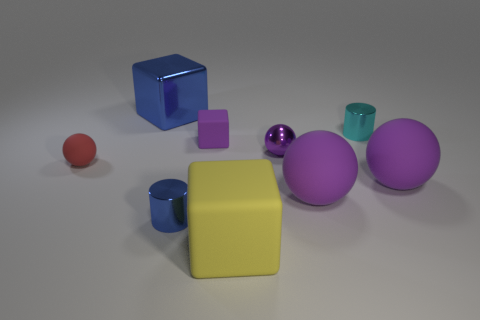There is a thing that is the same color as the large metallic block; what is its material?
Give a very brief answer. Metal. Are there more small balls that are in front of the tiny purple shiny thing than small spheres that are in front of the yellow cube?
Give a very brief answer. Yes. What number of tiny red objects are the same shape as the cyan shiny thing?
Provide a short and direct response. 0. How many things are either things that are in front of the big blue object or purple matte things in front of the metal ball?
Offer a very short reply. 8. What is the small thing that is left of the small blue object in front of the rubber thing that is behind the small matte ball made of?
Make the answer very short. Rubber. There is a tiny rubber object to the right of the large blue shiny object; is it the same color as the large shiny thing?
Make the answer very short. No. What is the block that is on the right side of the tiny blue metallic object and behind the small blue metal cylinder made of?
Your answer should be very brief. Rubber. Are there any rubber things of the same size as the blue cylinder?
Your answer should be compact. Yes. What number of purple blocks are there?
Give a very brief answer. 1. There is a tiny cyan cylinder; how many objects are on the left side of it?
Offer a terse response. 7. 